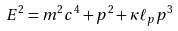<formula> <loc_0><loc_0><loc_500><loc_500>E ^ { 2 } = m ^ { 2 } c ^ { 4 } + p ^ { 2 } + \kappa \ell _ { p } p ^ { 3 }</formula> 